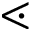Convert formula to latex. <formula><loc_0><loc_0><loc_500><loc_500>\leq s s d o t</formula> 